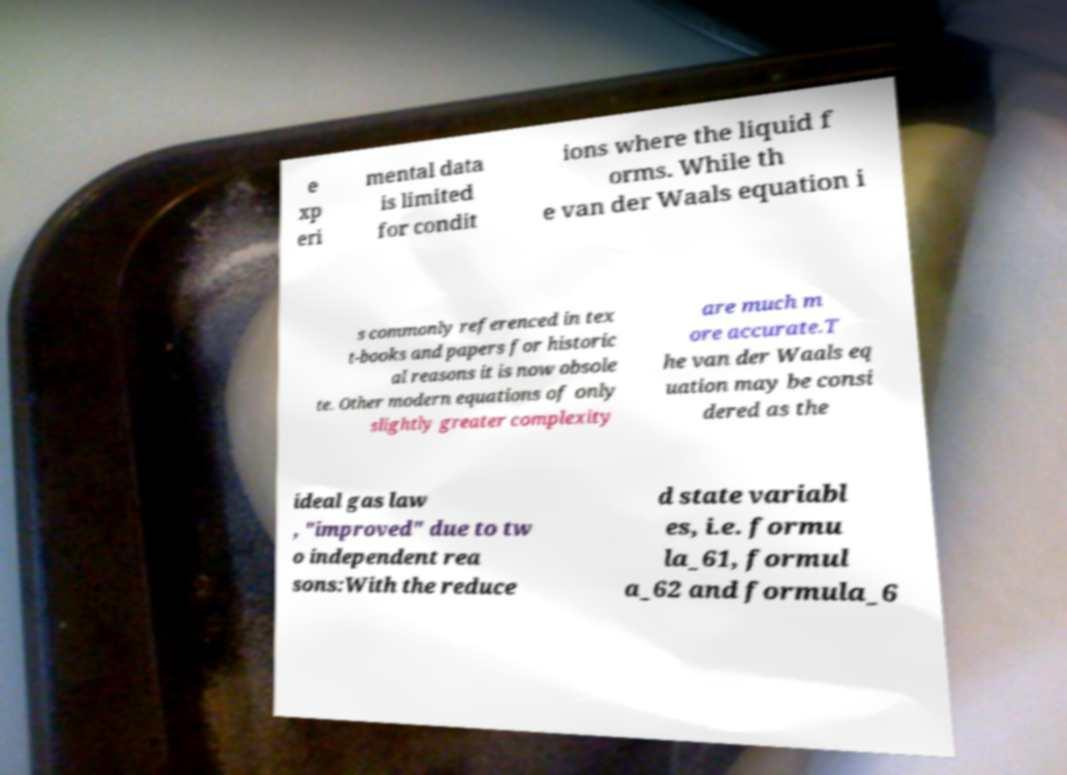Can you read and provide the text displayed in the image?This photo seems to have some interesting text. Can you extract and type it out for me? e xp eri mental data is limited for condit ions where the liquid f orms. While th e van der Waals equation i s commonly referenced in tex t-books and papers for historic al reasons it is now obsole te. Other modern equations of only slightly greater complexity are much m ore accurate.T he van der Waals eq uation may be consi dered as the ideal gas law , "improved" due to tw o independent rea sons:With the reduce d state variabl es, i.e. formu la_61, formul a_62 and formula_6 